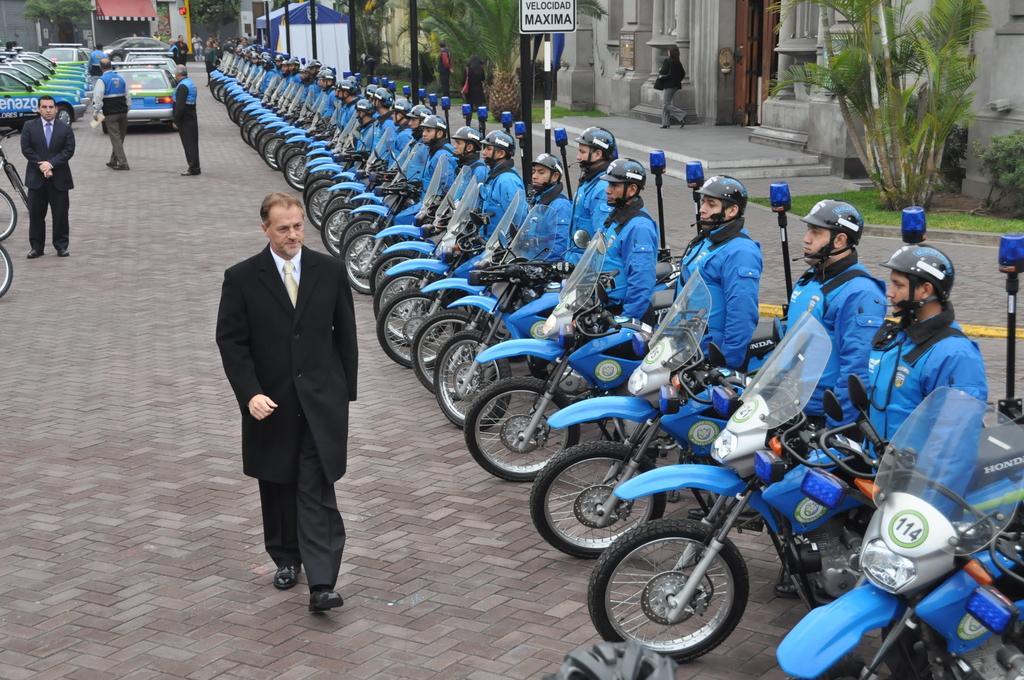Can you describe this image briefly? This image consists of motorcycles and people are standing beside motorcycles. There are cars, there is a building on the top. There are plants on the top right corner. There is a person in the middle who is walking. He is wearing black color dress. 